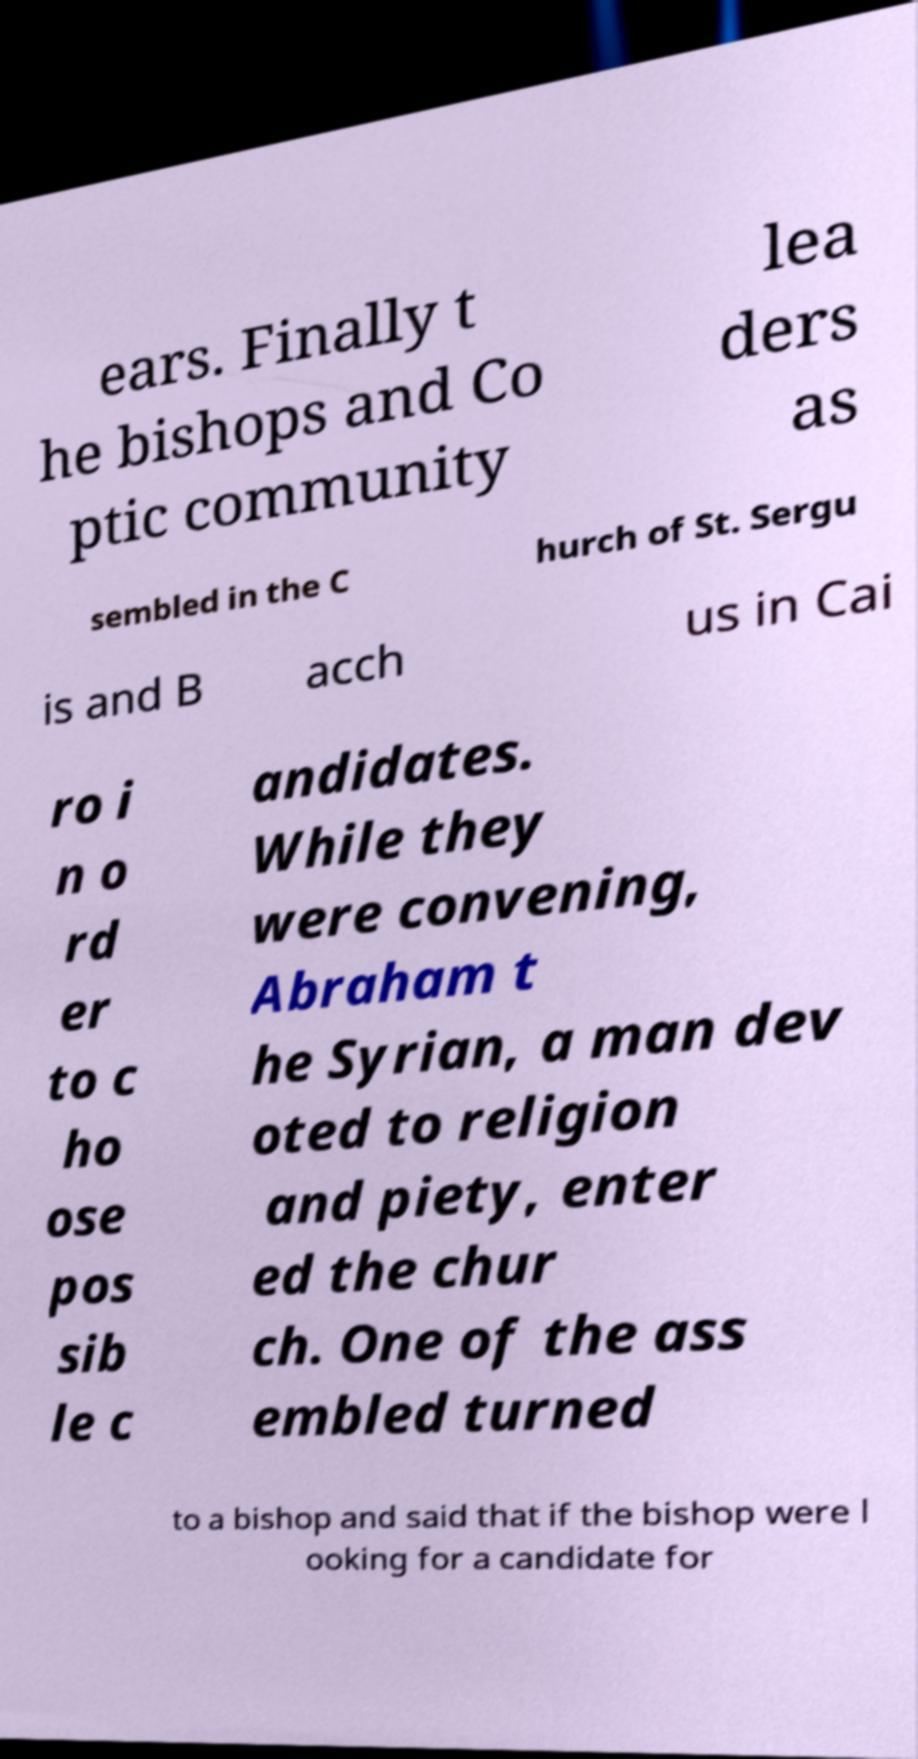What messages or text are displayed in this image? I need them in a readable, typed format. ears. Finally t he bishops and Co ptic community lea ders as sembled in the C hurch of St. Sergu is and B acch us in Cai ro i n o rd er to c ho ose pos sib le c andidates. While they were convening, Abraham t he Syrian, a man dev oted to religion and piety, enter ed the chur ch. One of the ass embled turned to a bishop and said that if the bishop were l ooking for a candidate for 